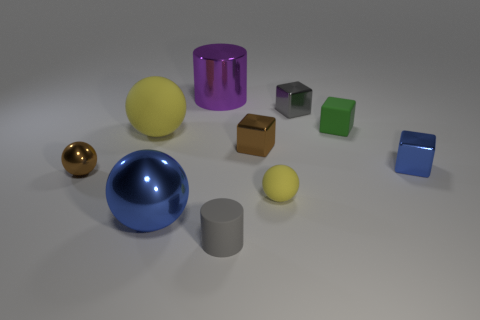What number of objects are either brown objects behind the small brown shiny ball or tiny brown metal spheres?
Your response must be concise. 2. Is the number of small gray cubes in front of the blue block greater than the number of large purple metallic cylinders that are behind the large yellow sphere?
Offer a terse response. No. There is a metallic cube that is the same color as the large shiny sphere; what size is it?
Make the answer very short. Small. Does the brown metallic ball have the same size as the metal block behind the tiny green thing?
Your answer should be very brief. Yes. What number of cylinders are either big cyan objects or big purple shiny objects?
Your answer should be compact. 1. There is a cube that is made of the same material as the gray cylinder; what is its size?
Your response must be concise. Small. Is the size of the shiny ball that is left of the large yellow object the same as the matte sphere that is to the right of the gray rubber thing?
Your response must be concise. Yes. What number of things are either small yellow cylinders or green things?
Keep it short and to the point. 1. The small gray rubber thing is what shape?
Give a very brief answer. Cylinder. There is a brown metal object that is the same shape as the large blue shiny object; what is its size?
Provide a short and direct response. Small. 